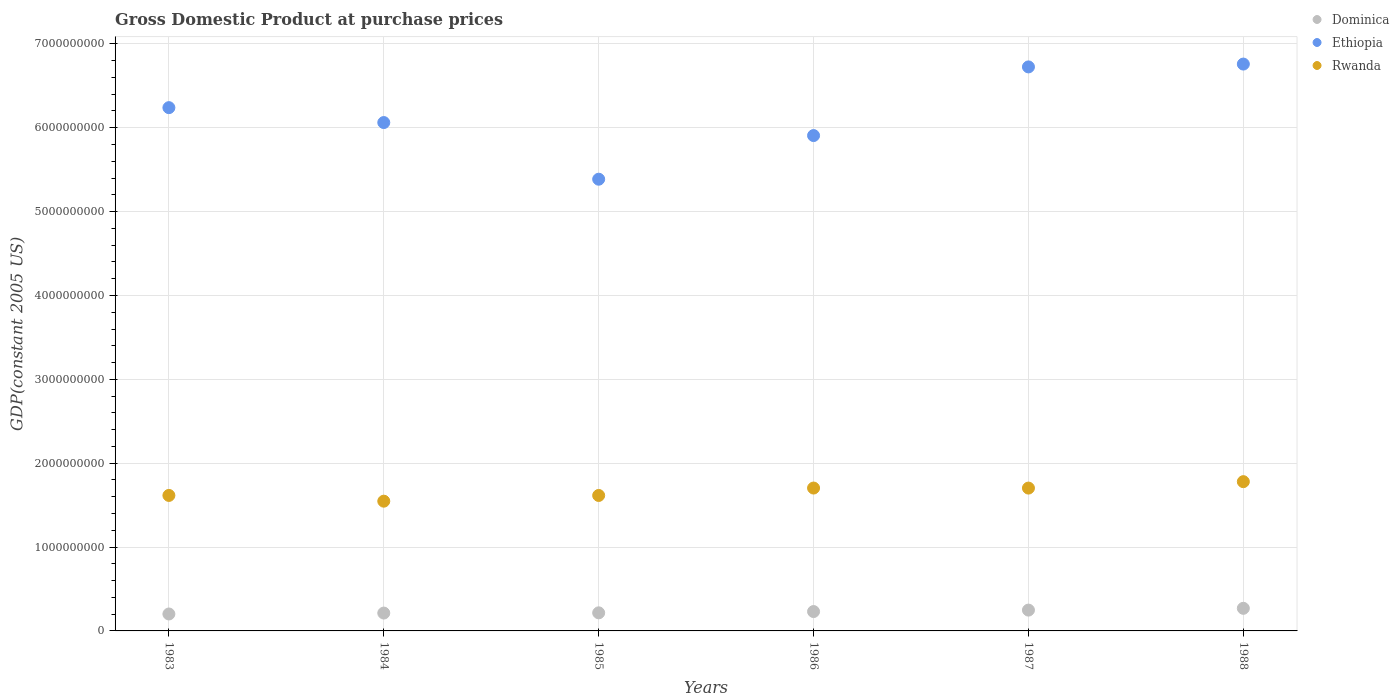What is the GDP at purchase prices in Rwanda in 1987?
Offer a very short reply. 1.70e+09. Across all years, what is the maximum GDP at purchase prices in Dominica?
Keep it short and to the point. 2.70e+08. Across all years, what is the minimum GDP at purchase prices in Rwanda?
Your answer should be very brief. 1.55e+09. In which year was the GDP at purchase prices in Ethiopia maximum?
Make the answer very short. 1988. What is the total GDP at purchase prices in Rwanda in the graph?
Keep it short and to the point. 9.96e+09. What is the difference between the GDP at purchase prices in Dominica in 1983 and that in 1984?
Give a very brief answer. -1.10e+07. What is the difference between the GDP at purchase prices in Dominica in 1984 and the GDP at purchase prices in Ethiopia in 1987?
Your answer should be compact. -6.51e+09. What is the average GDP at purchase prices in Rwanda per year?
Offer a terse response. 1.66e+09. In the year 1988, what is the difference between the GDP at purchase prices in Dominica and GDP at purchase prices in Ethiopia?
Your response must be concise. -6.49e+09. In how many years, is the GDP at purchase prices in Rwanda greater than 6400000000 US$?
Your answer should be compact. 0. What is the ratio of the GDP at purchase prices in Dominica in 1986 to that in 1987?
Provide a short and direct response. 0.93. Is the GDP at purchase prices in Ethiopia in 1984 less than that in 1988?
Provide a succinct answer. Yes. Is the difference between the GDP at purchase prices in Dominica in 1984 and 1987 greater than the difference between the GDP at purchase prices in Ethiopia in 1984 and 1987?
Make the answer very short. Yes. What is the difference between the highest and the second highest GDP at purchase prices in Ethiopia?
Give a very brief answer. 3.39e+07. What is the difference between the highest and the lowest GDP at purchase prices in Ethiopia?
Your answer should be very brief. 1.37e+09. In how many years, is the GDP at purchase prices in Ethiopia greater than the average GDP at purchase prices in Ethiopia taken over all years?
Offer a very short reply. 3. Is the GDP at purchase prices in Rwanda strictly greater than the GDP at purchase prices in Dominica over the years?
Provide a succinct answer. Yes. How many years are there in the graph?
Your answer should be very brief. 6. Are the values on the major ticks of Y-axis written in scientific E-notation?
Your answer should be compact. No. Does the graph contain any zero values?
Your answer should be compact. No. Where does the legend appear in the graph?
Your answer should be compact. Top right. How are the legend labels stacked?
Your answer should be compact. Vertical. What is the title of the graph?
Give a very brief answer. Gross Domestic Product at purchase prices. Does "Uganda" appear as one of the legend labels in the graph?
Ensure brevity in your answer.  No. What is the label or title of the Y-axis?
Your answer should be very brief. GDP(constant 2005 US). What is the GDP(constant 2005 US) of Dominica in 1983?
Provide a short and direct response. 2.02e+08. What is the GDP(constant 2005 US) in Ethiopia in 1983?
Keep it short and to the point. 6.24e+09. What is the GDP(constant 2005 US) of Rwanda in 1983?
Provide a short and direct response. 1.62e+09. What is the GDP(constant 2005 US) in Dominica in 1984?
Give a very brief answer. 2.13e+08. What is the GDP(constant 2005 US) of Ethiopia in 1984?
Provide a short and direct response. 6.06e+09. What is the GDP(constant 2005 US) of Rwanda in 1984?
Your answer should be compact. 1.55e+09. What is the GDP(constant 2005 US) of Dominica in 1985?
Offer a terse response. 2.16e+08. What is the GDP(constant 2005 US) in Ethiopia in 1985?
Your answer should be very brief. 5.39e+09. What is the GDP(constant 2005 US) in Rwanda in 1985?
Make the answer very short. 1.62e+09. What is the GDP(constant 2005 US) in Dominica in 1986?
Provide a succinct answer. 2.31e+08. What is the GDP(constant 2005 US) in Ethiopia in 1986?
Provide a short and direct response. 5.91e+09. What is the GDP(constant 2005 US) in Rwanda in 1986?
Ensure brevity in your answer.  1.70e+09. What is the GDP(constant 2005 US) of Dominica in 1987?
Your answer should be compact. 2.48e+08. What is the GDP(constant 2005 US) in Ethiopia in 1987?
Your answer should be very brief. 6.73e+09. What is the GDP(constant 2005 US) in Rwanda in 1987?
Give a very brief answer. 1.70e+09. What is the GDP(constant 2005 US) of Dominica in 1988?
Provide a succinct answer. 2.70e+08. What is the GDP(constant 2005 US) in Ethiopia in 1988?
Your response must be concise. 6.76e+09. What is the GDP(constant 2005 US) in Rwanda in 1988?
Make the answer very short. 1.78e+09. Across all years, what is the maximum GDP(constant 2005 US) in Dominica?
Give a very brief answer. 2.70e+08. Across all years, what is the maximum GDP(constant 2005 US) of Ethiopia?
Your response must be concise. 6.76e+09. Across all years, what is the maximum GDP(constant 2005 US) in Rwanda?
Your answer should be compact. 1.78e+09. Across all years, what is the minimum GDP(constant 2005 US) in Dominica?
Give a very brief answer. 2.02e+08. Across all years, what is the minimum GDP(constant 2005 US) in Ethiopia?
Make the answer very short. 5.39e+09. Across all years, what is the minimum GDP(constant 2005 US) of Rwanda?
Give a very brief answer. 1.55e+09. What is the total GDP(constant 2005 US) in Dominica in the graph?
Provide a succinct answer. 1.38e+09. What is the total GDP(constant 2005 US) of Ethiopia in the graph?
Make the answer very short. 3.71e+1. What is the total GDP(constant 2005 US) in Rwanda in the graph?
Give a very brief answer. 9.96e+09. What is the difference between the GDP(constant 2005 US) of Dominica in 1983 and that in 1984?
Keep it short and to the point. -1.10e+07. What is the difference between the GDP(constant 2005 US) in Ethiopia in 1983 and that in 1984?
Ensure brevity in your answer.  1.78e+08. What is the difference between the GDP(constant 2005 US) in Rwanda in 1983 and that in 1984?
Provide a short and direct response. 6.85e+07. What is the difference between the GDP(constant 2005 US) in Dominica in 1983 and that in 1985?
Provide a succinct answer. -1.37e+07. What is the difference between the GDP(constant 2005 US) in Ethiopia in 1983 and that in 1985?
Make the answer very short. 8.53e+08. What is the difference between the GDP(constant 2005 US) in Rwanda in 1983 and that in 1985?
Ensure brevity in your answer.  4.00e+05. What is the difference between the GDP(constant 2005 US) in Dominica in 1983 and that in 1986?
Offer a terse response. -2.90e+07. What is the difference between the GDP(constant 2005 US) in Ethiopia in 1983 and that in 1986?
Your answer should be very brief. 3.33e+08. What is the difference between the GDP(constant 2005 US) in Rwanda in 1983 and that in 1986?
Your response must be concise. -8.80e+07. What is the difference between the GDP(constant 2005 US) of Dominica in 1983 and that in 1987?
Your answer should be very brief. -4.63e+07. What is the difference between the GDP(constant 2005 US) of Ethiopia in 1983 and that in 1987?
Your answer should be compact. -4.86e+08. What is the difference between the GDP(constant 2005 US) of Rwanda in 1983 and that in 1987?
Keep it short and to the point. -8.76e+07. What is the difference between the GDP(constant 2005 US) in Dominica in 1983 and that in 1988?
Your response must be concise. -6.76e+07. What is the difference between the GDP(constant 2005 US) of Ethiopia in 1983 and that in 1988?
Provide a short and direct response. -5.20e+08. What is the difference between the GDP(constant 2005 US) in Rwanda in 1983 and that in 1988?
Your answer should be compact. -1.64e+08. What is the difference between the GDP(constant 2005 US) of Dominica in 1984 and that in 1985?
Ensure brevity in your answer.  -2.74e+06. What is the difference between the GDP(constant 2005 US) of Ethiopia in 1984 and that in 1985?
Provide a succinct answer. 6.76e+08. What is the difference between the GDP(constant 2005 US) of Rwanda in 1984 and that in 1985?
Your answer should be very brief. -6.81e+07. What is the difference between the GDP(constant 2005 US) in Dominica in 1984 and that in 1986?
Provide a short and direct response. -1.80e+07. What is the difference between the GDP(constant 2005 US) of Ethiopia in 1984 and that in 1986?
Provide a short and direct response. 1.55e+08. What is the difference between the GDP(constant 2005 US) of Rwanda in 1984 and that in 1986?
Keep it short and to the point. -1.57e+08. What is the difference between the GDP(constant 2005 US) in Dominica in 1984 and that in 1987?
Give a very brief answer. -3.54e+07. What is the difference between the GDP(constant 2005 US) of Ethiopia in 1984 and that in 1987?
Your response must be concise. -6.63e+08. What is the difference between the GDP(constant 2005 US) in Rwanda in 1984 and that in 1987?
Your answer should be very brief. -1.56e+08. What is the difference between the GDP(constant 2005 US) in Dominica in 1984 and that in 1988?
Give a very brief answer. -5.66e+07. What is the difference between the GDP(constant 2005 US) of Ethiopia in 1984 and that in 1988?
Provide a succinct answer. -6.97e+08. What is the difference between the GDP(constant 2005 US) of Rwanda in 1984 and that in 1988?
Keep it short and to the point. -2.33e+08. What is the difference between the GDP(constant 2005 US) in Dominica in 1985 and that in 1986?
Offer a very short reply. -1.53e+07. What is the difference between the GDP(constant 2005 US) of Ethiopia in 1985 and that in 1986?
Make the answer very short. -5.20e+08. What is the difference between the GDP(constant 2005 US) of Rwanda in 1985 and that in 1986?
Provide a succinct answer. -8.84e+07. What is the difference between the GDP(constant 2005 US) in Dominica in 1985 and that in 1987?
Your answer should be compact. -3.26e+07. What is the difference between the GDP(constant 2005 US) in Ethiopia in 1985 and that in 1987?
Your response must be concise. -1.34e+09. What is the difference between the GDP(constant 2005 US) of Rwanda in 1985 and that in 1987?
Provide a succinct answer. -8.80e+07. What is the difference between the GDP(constant 2005 US) in Dominica in 1985 and that in 1988?
Your response must be concise. -5.39e+07. What is the difference between the GDP(constant 2005 US) in Ethiopia in 1985 and that in 1988?
Offer a terse response. -1.37e+09. What is the difference between the GDP(constant 2005 US) in Rwanda in 1985 and that in 1988?
Provide a short and direct response. -1.65e+08. What is the difference between the GDP(constant 2005 US) of Dominica in 1986 and that in 1987?
Provide a short and direct response. -1.74e+07. What is the difference between the GDP(constant 2005 US) in Ethiopia in 1986 and that in 1987?
Your response must be concise. -8.19e+08. What is the difference between the GDP(constant 2005 US) of Rwanda in 1986 and that in 1987?
Your response must be concise. 4.09e+05. What is the difference between the GDP(constant 2005 US) in Dominica in 1986 and that in 1988?
Give a very brief answer. -3.86e+07. What is the difference between the GDP(constant 2005 US) of Ethiopia in 1986 and that in 1988?
Offer a very short reply. -8.53e+08. What is the difference between the GDP(constant 2005 US) in Rwanda in 1986 and that in 1988?
Offer a terse response. -7.62e+07. What is the difference between the GDP(constant 2005 US) of Dominica in 1987 and that in 1988?
Your answer should be very brief. -2.13e+07. What is the difference between the GDP(constant 2005 US) in Ethiopia in 1987 and that in 1988?
Make the answer very short. -3.39e+07. What is the difference between the GDP(constant 2005 US) of Rwanda in 1987 and that in 1988?
Make the answer very short. -7.66e+07. What is the difference between the GDP(constant 2005 US) of Dominica in 1983 and the GDP(constant 2005 US) of Ethiopia in 1984?
Provide a short and direct response. -5.86e+09. What is the difference between the GDP(constant 2005 US) in Dominica in 1983 and the GDP(constant 2005 US) in Rwanda in 1984?
Keep it short and to the point. -1.35e+09. What is the difference between the GDP(constant 2005 US) in Ethiopia in 1983 and the GDP(constant 2005 US) in Rwanda in 1984?
Ensure brevity in your answer.  4.69e+09. What is the difference between the GDP(constant 2005 US) of Dominica in 1983 and the GDP(constant 2005 US) of Ethiopia in 1985?
Give a very brief answer. -5.18e+09. What is the difference between the GDP(constant 2005 US) in Dominica in 1983 and the GDP(constant 2005 US) in Rwanda in 1985?
Your answer should be compact. -1.41e+09. What is the difference between the GDP(constant 2005 US) of Ethiopia in 1983 and the GDP(constant 2005 US) of Rwanda in 1985?
Your answer should be very brief. 4.62e+09. What is the difference between the GDP(constant 2005 US) of Dominica in 1983 and the GDP(constant 2005 US) of Ethiopia in 1986?
Keep it short and to the point. -5.70e+09. What is the difference between the GDP(constant 2005 US) of Dominica in 1983 and the GDP(constant 2005 US) of Rwanda in 1986?
Keep it short and to the point. -1.50e+09. What is the difference between the GDP(constant 2005 US) in Ethiopia in 1983 and the GDP(constant 2005 US) in Rwanda in 1986?
Ensure brevity in your answer.  4.54e+09. What is the difference between the GDP(constant 2005 US) in Dominica in 1983 and the GDP(constant 2005 US) in Ethiopia in 1987?
Offer a very short reply. -6.52e+09. What is the difference between the GDP(constant 2005 US) in Dominica in 1983 and the GDP(constant 2005 US) in Rwanda in 1987?
Give a very brief answer. -1.50e+09. What is the difference between the GDP(constant 2005 US) of Ethiopia in 1983 and the GDP(constant 2005 US) of Rwanda in 1987?
Your response must be concise. 4.54e+09. What is the difference between the GDP(constant 2005 US) in Dominica in 1983 and the GDP(constant 2005 US) in Ethiopia in 1988?
Make the answer very short. -6.56e+09. What is the difference between the GDP(constant 2005 US) in Dominica in 1983 and the GDP(constant 2005 US) in Rwanda in 1988?
Provide a succinct answer. -1.58e+09. What is the difference between the GDP(constant 2005 US) in Ethiopia in 1983 and the GDP(constant 2005 US) in Rwanda in 1988?
Offer a very short reply. 4.46e+09. What is the difference between the GDP(constant 2005 US) of Dominica in 1984 and the GDP(constant 2005 US) of Ethiopia in 1985?
Give a very brief answer. -5.17e+09. What is the difference between the GDP(constant 2005 US) in Dominica in 1984 and the GDP(constant 2005 US) in Rwanda in 1985?
Keep it short and to the point. -1.40e+09. What is the difference between the GDP(constant 2005 US) in Ethiopia in 1984 and the GDP(constant 2005 US) in Rwanda in 1985?
Give a very brief answer. 4.45e+09. What is the difference between the GDP(constant 2005 US) of Dominica in 1984 and the GDP(constant 2005 US) of Ethiopia in 1986?
Your answer should be compact. -5.69e+09. What is the difference between the GDP(constant 2005 US) of Dominica in 1984 and the GDP(constant 2005 US) of Rwanda in 1986?
Your answer should be very brief. -1.49e+09. What is the difference between the GDP(constant 2005 US) in Ethiopia in 1984 and the GDP(constant 2005 US) in Rwanda in 1986?
Ensure brevity in your answer.  4.36e+09. What is the difference between the GDP(constant 2005 US) of Dominica in 1984 and the GDP(constant 2005 US) of Ethiopia in 1987?
Give a very brief answer. -6.51e+09. What is the difference between the GDP(constant 2005 US) of Dominica in 1984 and the GDP(constant 2005 US) of Rwanda in 1987?
Your response must be concise. -1.49e+09. What is the difference between the GDP(constant 2005 US) in Ethiopia in 1984 and the GDP(constant 2005 US) in Rwanda in 1987?
Offer a very short reply. 4.36e+09. What is the difference between the GDP(constant 2005 US) in Dominica in 1984 and the GDP(constant 2005 US) in Ethiopia in 1988?
Make the answer very short. -6.55e+09. What is the difference between the GDP(constant 2005 US) of Dominica in 1984 and the GDP(constant 2005 US) of Rwanda in 1988?
Make the answer very short. -1.57e+09. What is the difference between the GDP(constant 2005 US) in Ethiopia in 1984 and the GDP(constant 2005 US) in Rwanda in 1988?
Your answer should be very brief. 4.28e+09. What is the difference between the GDP(constant 2005 US) in Dominica in 1985 and the GDP(constant 2005 US) in Ethiopia in 1986?
Offer a very short reply. -5.69e+09. What is the difference between the GDP(constant 2005 US) in Dominica in 1985 and the GDP(constant 2005 US) in Rwanda in 1986?
Keep it short and to the point. -1.49e+09. What is the difference between the GDP(constant 2005 US) in Ethiopia in 1985 and the GDP(constant 2005 US) in Rwanda in 1986?
Your response must be concise. 3.68e+09. What is the difference between the GDP(constant 2005 US) in Dominica in 1985 and the GDP(constant 2005 US) in Ethiopia in 1987?
Your answer should be compact. -6.51e+09. What is the difference between the GDP(constant 2005 US) in Dominica in 1985 and the GDP(constant 2005 US) in Rwanda in 1987?
Provide a succinct answer. -1.49e+09. What is the difference between the GDP(constant 2005 US) of Ethiopia in 1985 and the GDP(constant 2005 US) of Rwanda in 1987?
Keep it short and to the point. 3.68e+09. What is the difference between the GDP(constant 2005 US) of Dominica in 1985 and the GDP(constant 2005 US) of Ethiopia in 1988?
Give a very brief answer. -6.54e+09. What is the difference between the GDP(constant 2005 US) in Dominica in 1985 and the GDP(constant 2005 US) in Rwanda in 1988?
Keep it short and to the point. -1.56e+09. What is the difference between the GDP(constant 2005 US) of Ethiopia in 1985 and the GDP(constant 2005 US) of Rwanda in 1988?
Your response must be concise. 3.61e+09. What is the difference between the GDP(constant 2005 US) of Dominica in 1986 and the GDP(constant 2005 US) of Ethiopia in 1987?
Ensure brevity in your answer.  -6.49e+09. What is the difference between the GDP(constant 2005 US) in Dominica in 1986 and the GDP(constant 2005 US) in Rwanda in 1987?
Offer a very short reply. -1.47e+09. What is the difference between the GDP(constant 2005 US) in Ethiopia in 1986 and the GDP(constant 2005 US) in Rwanda in 1987?
Provide a short and direct response. 4.20e+09. What is the difference between the GDP(constant 2005 US) in Dominica in 1986 and the GDP(constant 2005 US) in Ethiopia in 1988?
Offer a terse response. -6.53e+09. What is the difference between the GDP(constant 2005 US) in Dominica in 1986 and the GDP(constant 2005 US) in Rwanda in 1988?
Provide a succinct answer. -1.55e+09. What is the difference between the GDP(constant 2005 US) of Ethiopia in 1986 and the GDP(constant 2005 US) of Rwanda in 1988?
Give a very brief answer. 4.13e+09. What is the difference between the GDP(constant 2005 US) of Dominica in 1987 and the GDP(constant 2005 US) of Ethiopia in 1988?
Your answer should be compact. -6.51e+09. What is the difference between the GDP(constant 2005 US) of Dominica in 1987 and the GDP(constant 2005 US) of Rwanda in 1988?
Your answer should be compact. -1.53e+09. What is the difference between the GDP(constant 2005 US) of Ethiopia in 1987 and the GDP(constant 2005 US) of Rwanda in 1988?
Your answer should be very brief. 4.95e+09. What is the average GDP(constant 2005 US) of Dominica per year?
Provide a short and direct response. 2.30e+08. What is the average GDP(constant 2005 US) of Ethiopia per year?
Provide a succinct answer. 6.18e+09. What is the average GDP(constant 2005 US) of Rwanda per year?
Offer a very short reply. 1.66e+09. In the year 1983, what is the difference between the GDP(constant 2005 US) in Dominica and GDP(constant 2005 US) in Ethiopia?
Ensure brevity in your answer.  -6.04e+09. In the year 1983, what is the difference between the GDP(constant 2005 US) of Dominica and GDP(constant 2005 US) of Rwanda?
Provide a succinct answer. -1.41e+09. In the year 1983, what is the difference between the GDP(constant 2005 US) of Ethiopia and GDP(constant 2005 US) of Rwanda?
Your answer should be very brief. 4.62e+09. In the year 1984, what is the difference between the GDP(constant 2005 US) of Dominica and GDP(constant 2005 US) of Ethiopia?
Offer a very short reply. -5.85e+09. In the year 1984, what is the difference between the GDP(constant 2005 US) of Dominica and GDP(constant 2005 US) of Rwanda?
Your answer should be compact. -1.33e+09. In the year 1984, what is the difference between the GDP(constant 2005 US) in Ethiopia and GDP(constant 2005 US) in Rwanda?
Your answer should be compact. 4.51e+09. In the year 1985, what is the difference between the GDP(constant 2005 US) in Dominica and GDP(constant 2005 US) in Ethiopia?
Offer a very short reply. -5.17e+09. In the year 1985, what is the difference between the GDP(constant 2005 US) of Dominica and GDP(constant 2005 US) of Rwanda?
Keep it short and to the point. -1.40e+09. In the year 1985, what is the difference between the GDP(constant 2005 US) of Ethiopia and GDP(constant 2005 US) of Rwanda?
Provide a short and direct response. 3.77e+09. In the year 1986, what is the difference between the GDP(constant 2005 US) in Dominica and GDP(constant 2005 US) in Ethiopia?
Ensure brevity in your answer.  -5.68e+09. In the year 1986, what is the difference between the GDP(constant 2005 US) of Dominica and GDP(constant 2005 US) of Rwanda?
Give a very brief answer. -1.47e+09. In the year 1986, what is the difference between the GDP(constant 2005 US) in Ethiopia and GDP(constant 2005 US) in Rwanda?
Give a very brief answer. 4.20e+09. In the year 1987, what is the difference between the GDP(constant 2005 US) in Dominica and GDP(constant 2005 US) in Ethiopia?
Your answer should be very brief. -6.48e+09. In the year 1987, what is the difference between the GDP(constant 2005 US) of Dominica and GDP(constant 2005 US) of Rwanda?
Provide a short and direct response. -1.45e+09. In the year 1987, what is the difference between the GDP(constant 2005 US) of Ethiopia and GDP(constant 2005 US) of Rwanda?
Offer a terse response. 5.02e+09. In the year 1988, what is the difference between the GDP(constant 2005 US) in Dominica and GDP(constant 2005 US) in Ethiopia?
Offer a terse response. -6.49e+09. In the year 1988, what is the difference between the GDP(constant 2005 US) in Dominica and GDP(constant 2005 US) in Rwanda?
Give a very brief answer. -1.51e+09. In the year 1988, what is the difference between the GDP(constant 2005 US) of Ethiopia and GDP(constant 2005 US) of Rwanda?
Provide a short and direct response. 4.98e+09. What is the ratio of the GDP(constant 2005 US) of Dominica in 1983 to that in 1984?
Ensure brevity in your answer.  0.95. What is the ratio of the GDP(constant 2005 US) of Ethiopia in 1983 to that in 1984?
Your answer should be very brief. 1.03. What is the ratio of the GDP(constant 2005 US) of Rwanda in 1983 to that in 1984?
Keep it short and to the point. 1.04. What is the ratio of the GDP(constant 2005 US) of Dominica in 1983 to that in 1985?
Offer a very short reply. 0.94. What is the ratio of the GDP(constant 2005 US) in Ethiopia in 1983 to that in 1985?
Make the answer very short. 1.16. What is the ratio of the GDP(constant 2005 US) of Dominica in 1983 to that in 1986?
Your answer should be very brief. 0.87. What is the ratio of the GDP(constant 2005 US) of Ethiopia in 1983 to that in 1986?
Provide a short and direct response. 1.06. What is the ratio of the GDP(constant 2005 US) in Rwanda in 1983 to that in 1986?
Offer a very short reply. 0.95. What is the ratio of the GDP(constant 2005 US) in Dominica in 1983 to that in 1987?
Provide a succinct answer. 0.81. What is the ratio of the GDP(constant 2005 US) of Ethiopia in 1983 to that in 1987?
Offer a very short reply. 0.93. What is the ratio of the GDP(constant 2005 US) in Rwanda in 1983 to that in 1987?
Make the answer very short. 0.95. What is the ratio of the GDP(constant 2005 US) of Dominica in 1983 to that in 1988?
Keep it short and to the point. 0.75. What is the ratio of the GDP(constant 2005 US) in Rwanda in 1983 to that in 1988?
Ensure brevity in your answer.  0.91. What is the ratio of the GDP(constant 2005 US) in Dominica in 1984 to that in 1985?
Make the answer very short. 0.99. What is the ratio of the GDP(constant 2005 US) of Ethiopia in 1984 to that in 1985?
Provide a succinct answer. 1.13. What is the ratio of the GDP(constant 2005 US) of Rwanda in 1984 to that in 1985?
Offer a terse response. 0.96. What is the ratio of the GDP(constant 2005 US) of Dominica in 1984 to that in 1986?
Your answer should be very brief. 0.92. What is the ratio of the GDP(constant 2005 US) of Ethiopia in 1984 to that in 1986?
Provide a succinct answer. 1.03. What is the ratio of the GDP(constant 2005 US) in Rwanda in 1984 to that in 1986?
Offer a terse response. 0.91. What is the ratio of the GDP(constant 2005 US) of Dominica in 1984 to that in 1987?
Offer a very short reply. 0.86. What is the ratio of the GDP(constant 2005 US) of Ethiopia in 1984 to that in 1987?
Your answer should be compact. 0.9. What is the ratio of the GDP(constant 2005 US) in Rwanda in 1984 to that in 1987?
Keep it short and to the point. 0.91. What is the ratio of the GDP(constant 2005 US) of Dominica in 1984 to that in 1988?
Your answer should be compact. 0.79. What is the ratio of the GDP(constant 2005 US) of Ethiopia in 1984 to that in 1988?
Offer a very short reply. 0.9. What is the ratio of the GDP(constant 2005 US) of Rwanda in 1984 to that in 1988?
Keep it short and to the point. 0.87. What is the ratio of the GDP(constant 2005 US) in Dominica in 1985 to that in 1986?
Offer a very short reply. 0.93. What is the ratio of the GDP(constant 2005 US) in Ethiopia in 1985 to that in 1986?
Your response must be concise. 0.91. What is the ratio of the GDP(constant 2005 US) in Rwanda in 1985 to that in 1986?
Provide a succinct answer. 0.95. What is the ratio of the GDP(constant 2005 US) in Dominica in 1985 to that in 1987?
Your answer should be compact. 0.87. What is the ratio of the GDP(constant 2005 US) of Ethiopia in 1985 to that in 1987?
Your response must be concise. 0.8. What is the ratio of the GDP(constant 2005 US) in Rwanda in 1985 to that in 1987?
Provide a succinct answer. 0.95. What is the ratio of the GDP(constant 2005 US) of Dominica in 1985 to that in 1988?
Your answer should be compact. 0.8. What is the ratio of the GDP(constant 2005 US) of Ethiopia in 1985 to that in 1988?
Provide a succinct answer. 0.8. What is the ratio of the GDP(constant 2005 US) in Rwanda in 1985 to that in 1988?
Offer a very short reply. 0.91. What is the ratio of the GDP(constant 2005 US) in Dominica in 1986 to that in 1987?
Make the answer very short. 0.93. What is the ratio of the GDP(constant 2005 US) of Ethiopia in 1986 to that in 1987?
Give a very brief answer. 0.88. What is the ratio of the GDP(constant 2005 US) in Rwanda in 1986 to that in 1987?
Make the answer very short. 1. What is the ratio of the GDP(constant 2005 US) in Dominica in 1986 to that in 1988?
Ensure brevity in your answer.  0.86. What is the ratio of the GDP(constant 2005 US) in Ethiopia in 1986 to that in 1988?
Keep it short and to the point. 0.87. What is the ratio of the GDP(constant 2005 US) in Rwanda in 1986 to that in 1988?
Your answer should be compact. 0.96. What is the ratio of the GDP(constant 2005 US) in Dominica in 1987 to that in 1988?
Ensure brevity in your answer.  0.92. What is the ratio of the GDP(constant 2005 US) in Rwanda in 1987 to that in 1988?
Your answer should be compact. 0.96. What is the difference between the highest and the second highest GDP(constant 2005 US) in Dominica?
Ensure brevity in your answer.  2.13e+07. What is the difference between the highest and the second highest GDP(constant 2005 US) of Ethiopia?
Your response must be concise. 3.39e+07. What is the difference between the highest and the second highest GDP(constant 2005 US) of Rwanda?
Provide a short and direct response. 7.62e+07. What is the difference between the highest and the lowest GDP(constant 2005 US) of Dominica?
Your answer should be very brief. 6.76e+07. What is the difference between the highest and the lowest GDP(constant 2005 US) in Ethiopia?
Your answer should be compact. 1.37e+09. What is the difference between the highest and the lowest GDP(constant 2005 US) of Rwanda?
Give a very brief answer. 2.33e+08. 